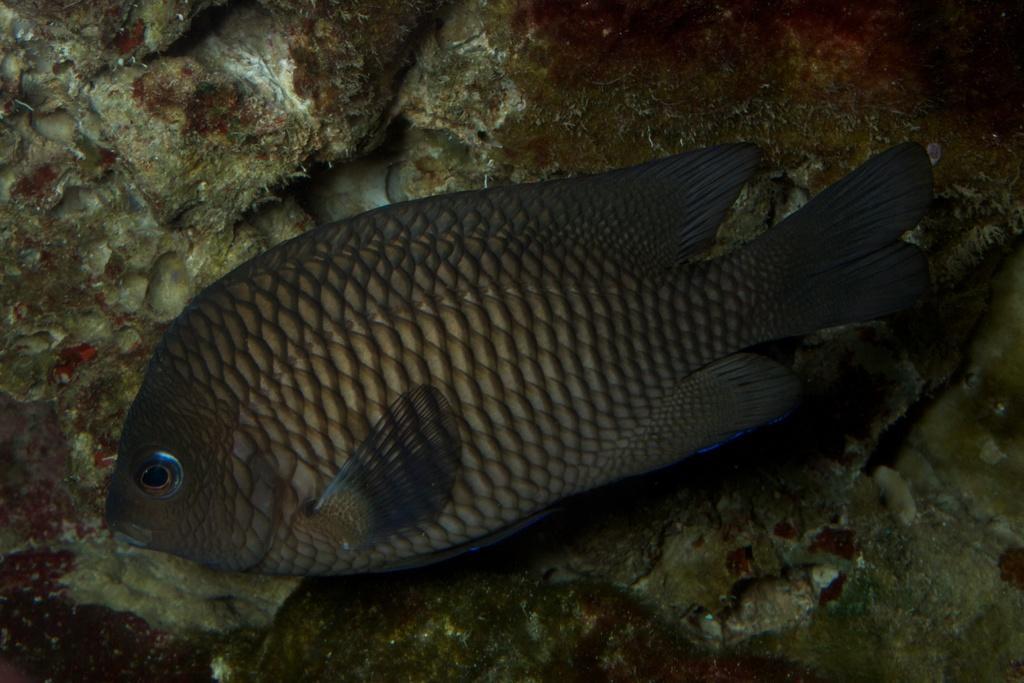Describe this image in one or two sentences. We can see fish on the surface. 